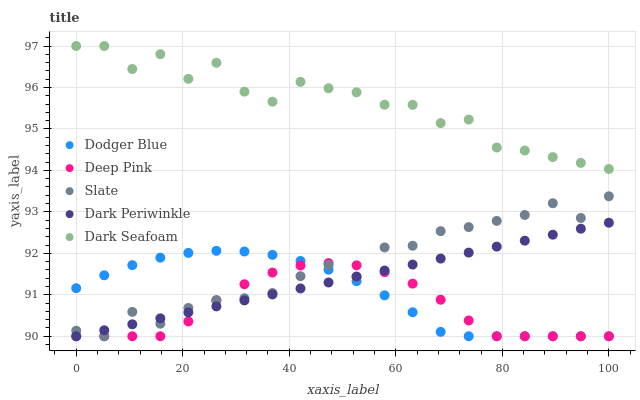Does Deep Pink have the minimum area under the curve?
Answer yes or no. Yes. Does Dark Seafoam have the maximum area under the curve?
Answer yes or no. Yes. Does Dodger Blue have the minimum area under the curve?
Answer yes or no. No. Does Dodger Blue have the maximum area under the curve?
Answer yes or no. No. Is Dark Periwinkle the smoothest?
Answer yes or no. Yes. Is Dark Seafoam the roughest?
Answer yes or no. Yes. Is Deep Pink the smoothest?
Answer yes or no. No. Is Deep Pink the roughest?
Answer yes or no. No. Does Slate have the lowest value?
Answer yes or no. Yes. Does Dark Seafoam have the lowest value?
Answer yes or no. No. Does Dark Seafoam have the highest value?
Answer yes or no. Yes. Does Dodger Blue have the highest value?
Answer yes or no. No. Is Slate less than Dark Seafoam?
Answer yes or no. Yes. Is Dark Seafoam greater than Deep Pink?
Answer yes or no. Yes. Does Slate intersect Dodger Blue?
Answer yes or no. Yes. Is Slate less than Dodger Blue?
Answer yes or no. No. Is Slate greater than Dodger Blue?
Answer yes or no. No. Does Slate intersect Dark Seafoam?
Answer yes or no. No. 